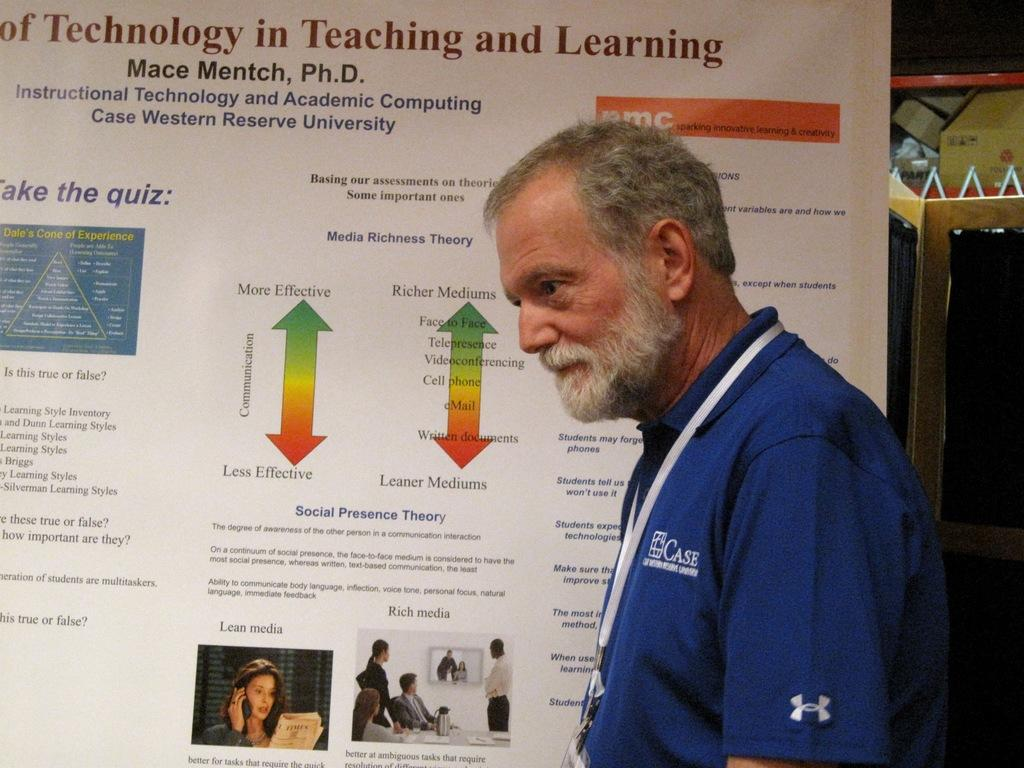Provide a one-sentence caption for the provided image. An older gentleman from Case Western Reserve University stands in front of an informative notice board. 